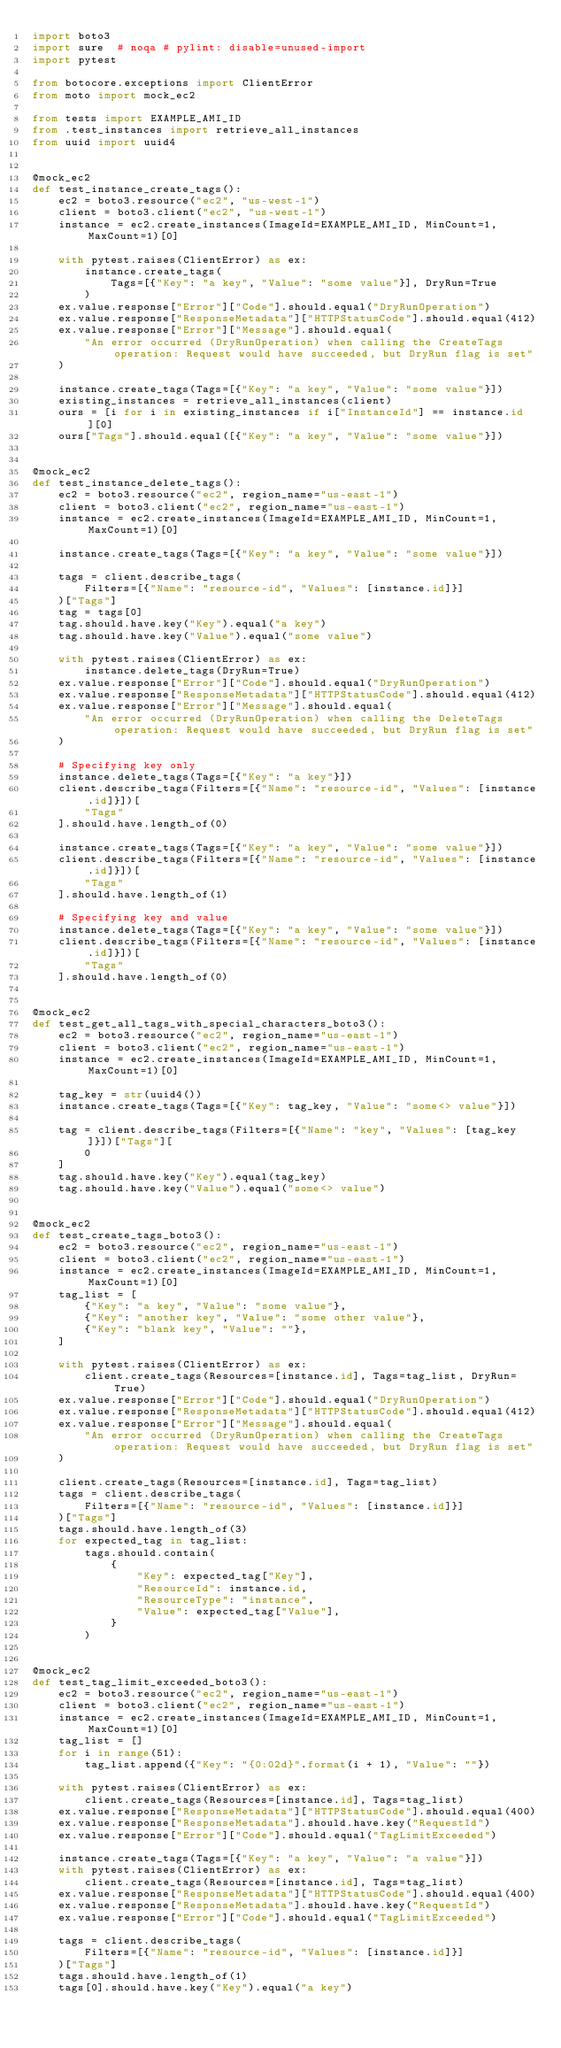Convert code to text. <code><loc_0><loc_0><loc_500><loc_500><_Python_>import boto3
import sure  # noqa # pylint: disable=unused-import
import pytest

from botocore.exceptions import ClientError
from moto import mock_ec2

from tests import EXAMPLE_AMI_ID
from .test_instances import retrieve_all_instances
from uuid import uuid4


@mock_ec2
def test_instance_create_tags():
    ec2 = boto3.resource("ec2", "us-west-1")
    client = boto3.client("ec2", "us-west-1")
    instance = ec2.create_instances(ImageId=EXAMPLE_AMI_ID, MinCount=1, MaxCount=1)[0]

    with pytest.raises(ClientError) as ex:
        instance.create_tags(
            Tags=[{"Key": "a key", "Value": "some value"}], DryRun=True
        )
    ex.value.response["Error"]["Code"].should.equal("DryRunOperation")
    ex.value.response["ResponseMetadata"]["HTTPStatusCode"].should.equal(412)
    ex.value.response["Error"]["Message"].should.equal(
        "An error occurred (DryRunOperation) when calling the CreateTags operation: Request would have succeeded, but DryRun flag is set"
    )

    instance.create_tags(Tags=[{"Key": "a key", "Value": "some value"}])
    existing_instances = retrieve_all_instances(client)
    ours = [i for i in existing_instances if i["InstanceId"] == instance.id][0]
    ours["Tags"].should.equal([{"Key": "a key", "Value": "some value"}])


@mock_ec2
def test_instance_delete_tags():
    ec2 = boto3.resource("ec2", region_name="us-east-1")
    client = boto3.client("ec2", region_name="us-east-1")
    instance = ec2.create_instances(ImageId=EXAMPLE_AMI_ID, MinCount=1, MaxCount=1)[0]

    instance.create_tags(Tags=[{"Key": "a key", "Value": "some value"}])

    tags = client.describe_tags(
        Filters=[{"Name": "resource-id", "Values": [instance.id]}]
    )["Tags"]
    tag = tags[0]
    tag.should.have.key("Key").equal("a key")
    tag.should.have.key("Value").equal("some value")

    with pytest.raises(ClientError) as ex:
        instance.delete_tags(DryRun=True)
    ex.value.response["Error"]["Code"].should.equal("DryRunOperation")
    ex.value.response["ResponseMetadata"]["HTTPStatusCode"].should.equal(412)
    ex.value.response["Error"]["Message"].should.equal(
        "An error occurred (DryRunOperation) when calling the DeleteTags operation: Request would have succeeded, but DryRun flag is set"
    )

    # Specifying key only
    instance.delete_tags(Tags=[{"Key": "a key"}])
    client.describe_tags(Filters=[{"Name": "resource-id", "Values": [instance.id]}])[
        "Tags"
    ].should.have.length_of(0)

    instance.create_tags(Tags=[{"Key": "a key", "Value": "some value"}])
    client.describe_tags(Filters=[{"Name": "resource-id", "Values": [instance.id]}])[
        "Tags"
    ].should.have.length_of(1)

    # Specifying key and value
    instance.delete_tags(Tags=[{"Key": "a key", "Value": "some value"}])
    client.describe_tags(Filters=[{"Name": "resource-id", "Values": [instance.id]}])[
        "Tags"
    ].should.have.length_of(0)


@mock_ec2
def test_get_all_tags_with_special_characters_boto3():
    ec2 = boto3.resource("ec2", region_name="us-east-1")
    client = boto3.client("ec2", region_name="us-east-1")
    instance = ec2.create_instances(ImageId=EXAMPLE_AMI_ID, MinCount=1, MaxCount=1)[0]

    tag_key = str(uuid4())
    instance.create_tags(Tags=[{"Key": tag_key, "Value": "some<> value"}])

    tag = client.describe_tags(Filters=[{"Name": "key", "Values": [tag_key]}])["Tags"][
        0
    ]
    tag.should.have.key("Key").equal(tag_key)
    tag.should.have.key("Value").equal("some<> value")


@mock_ec2
def test_create_tags_boto3():
    ec2 = boto3.resource("ec2", region_name="us-east-1")
    client = boto3.client("ec2", region_name="us-east-1")
    instance = ec2.create_instances(ImageId=EXAMPLE_AMI_ID, MinCount=1, MaxCount=1)[0]
    tag_list = [
        {"Key": "a key", "Value": "some value"},
        {"Key": "another key", "Value": "some other value"},
        {"Key": "blank key", "Value": ""},
    ]

    with pytest.raises(ClientError) as ex:
        client.create_tags(Resources=[instance.id], Tags=tag_list, DryRun=True)
    ex.value.response["Error"]["Code"].should.equal("DryRunOperation")
    ex.value.response["ResponseMetadata"]["HTTPStatusCode"].should.equal(412)
    ex.value.response["Error"]["Message"].should.equal(
        "An error occurred (DryRunOperation) when calling the CreateTags operation: Request would have succeeded, but DryRun flag is set"
    )

    client.create_tags(Resources=[instance.id], Tags=tag_list)
    tags = client.describe_tags(
        Filters=[{"Name": "resource-id", "Values": [instance.id]}]
    )["Tags"]
    tags.should.have.length_of(3)
    for expected_tag in tag_list:
        tags.should.contain(
            {
                "Key": expected_tag["Key"],
                "ResourceId": instance.id,
                "ResourceType": "instance",
                "Value": expected_tag["Value"],
            }
        )


@mock_ec2
def test_tag_limit_exceeded_boto3():
    ec2 = boto3.resource("ec2", region_name="us-east-1")
    client = boto3.client("ec2", region_name="us-east-1")
    instance = ec2.create_instances(ImageId=EXAMPLE_AMI_ID, MinCount=1, MaxCount=1)[0]
    tag_list = []
    for i in range(51):
        tag_list.append({"Key": "{0:02d}".format(i + 1), "Value": ""})

    with pytest.raises(ClientError) as ex:
        client.create_tags(Resources=[instance.id], Tags=tag_list)
    ex.value.response["ResponseMetadata"]["HTTPStatusCode"].should.equal(400)
    ex.value.response["ResponseMetadata"].should.have.key("RequestId")
    ex.value.response["Error"]["Code"].should.equal("TagLimitExceeded")

    instance.create_tags(Tags=[{"Key": "a key", "Value": "a value"}])
    with pytest.raises(ClientError) as ex:
        client.create_tags(Resources=[instance.id], Tags=tag_list)
    ex.value.response["ResponseMetadata"]["HTTPStatusCode"].should.equal(400)
    ex.value.response["ResponseMetadata"].should.have.key("RequestId")
    ex.value.response["Error"]["Code"].should.equal("TagLimitExceeded")

    tags = client.describe_tags(
        Filters=[{"Name": "resource-id", "Values": [instance.id]}]
    )["Tags"]
    tags.should.have.length_of(1)
    tags[0].should.have.key("Key").equal("a key")</code> 